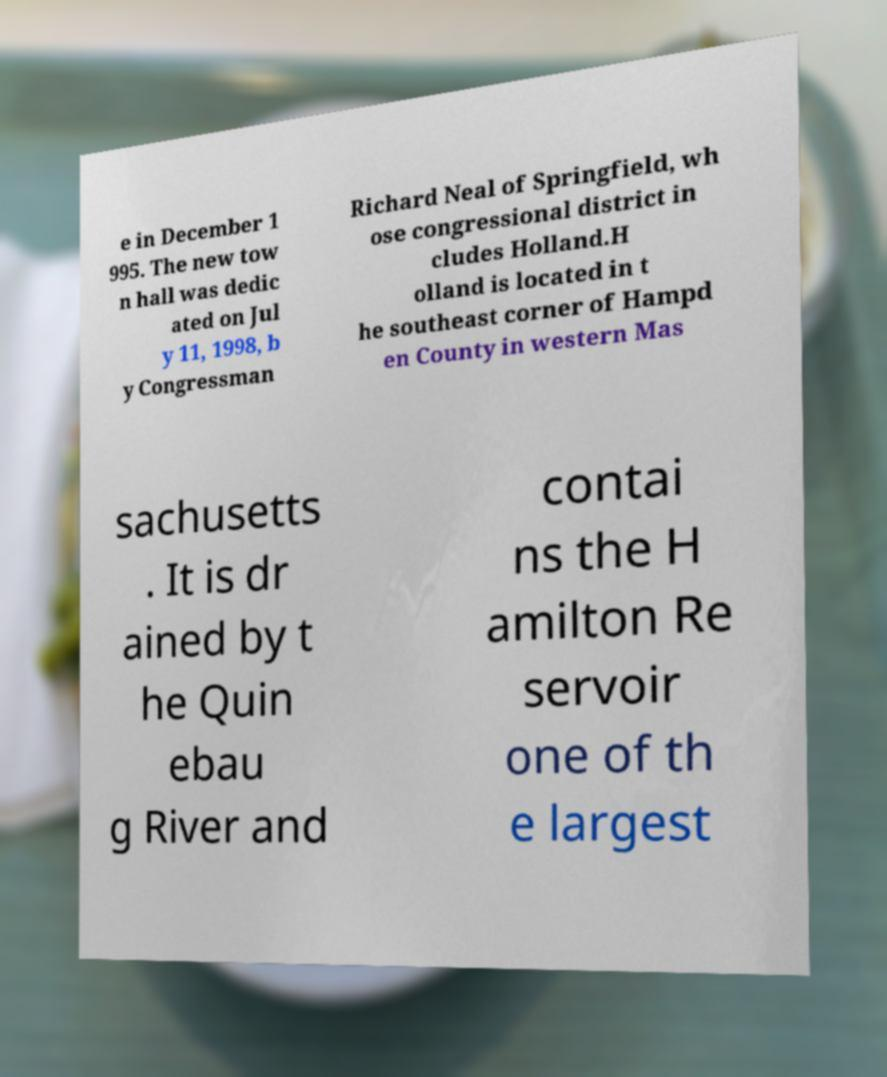There's text embedded in this image that I need extracted. Can you transcribe it verbatim? e in December 1 995. The new tow n hall was dedic ated on Jul y 11, 1998, b y Congressman Richard Neal of Springfield, wh ose congressional district in cludes Holland.H olland is located in t he southeast corner of Hampd en County in western Mas sachusetts . It is dr ained by t he Quin ebau g River and contai ns the H amilton Re servoir one of th e largest 